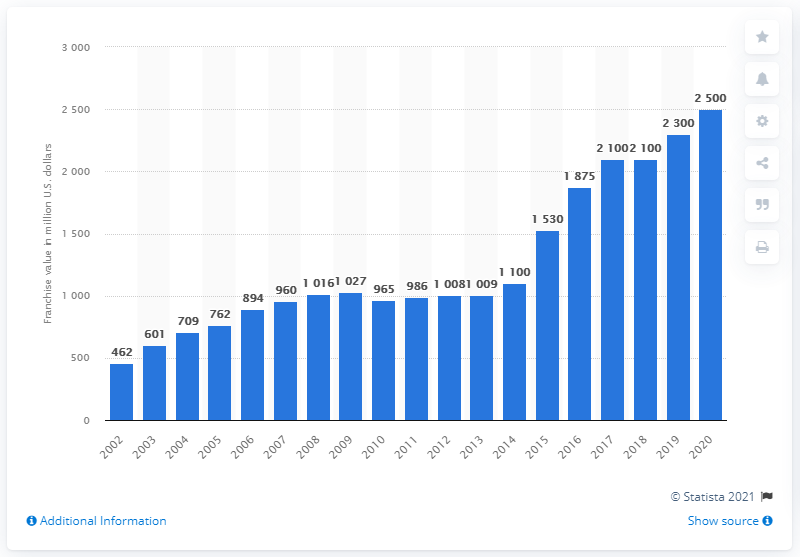List a handful of essential elements in this visual. In 2020, the franchise value of the Kansas City Chiefs was estimated to be approximately 2,500 dollars. 